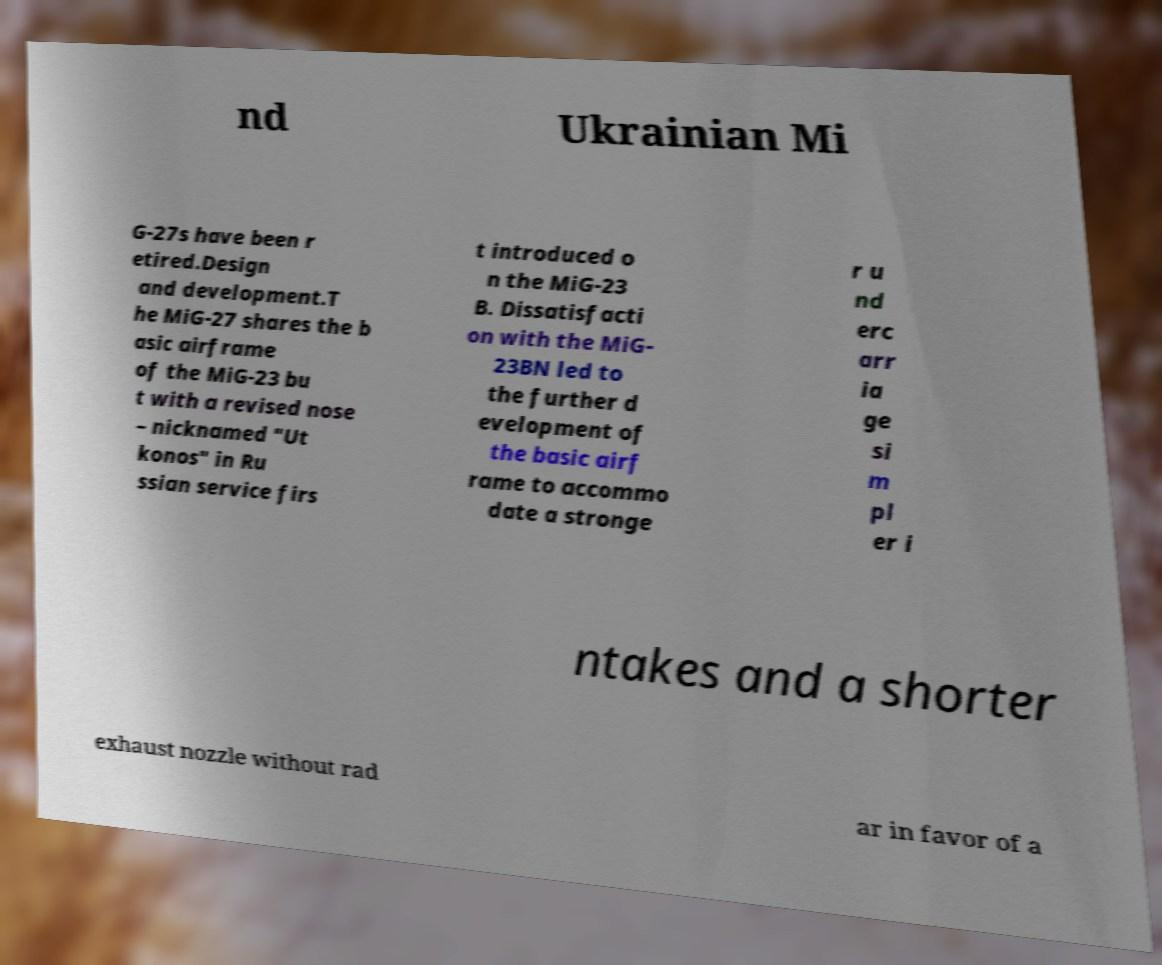What messages or text are displayed in this image? I need them in a readable, typed format. nd Ukrainian Mi G-27s have been r etired.Design and development.T he MiG-27 shares the b asic airframe of the MiG-23 bu t with a revised nose – nicknamed "Ut konos" in Ru ssian service firs t introduced o n the MiG-23 B. Dissatisfacti on with the MiG- 23BN led to the further d evelopment of the basic airf rame to accommo date a stronge r u nd erc arr ia ge si m pl er i ntakes and a shorter exhaust nozzle without rad ar in favor of a 